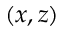Convert formula to latex. <formula><loc_0><loc_0><loc_500><loc_500>( x , z )</formula> 